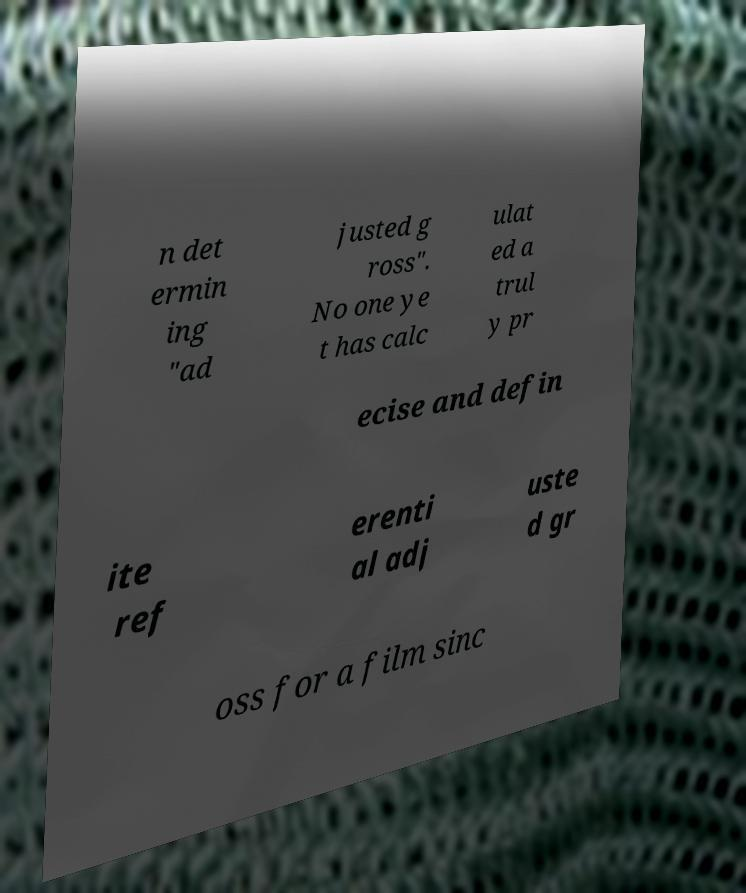What messages or text are displayed in this image? I need them in a readable, typed format. n det ermin ing "ad justed g ross". No one ye t has calc ulat ed a trul y pr ecise and defin ite ref erenti al adj uste d gr oss for a film sinc 